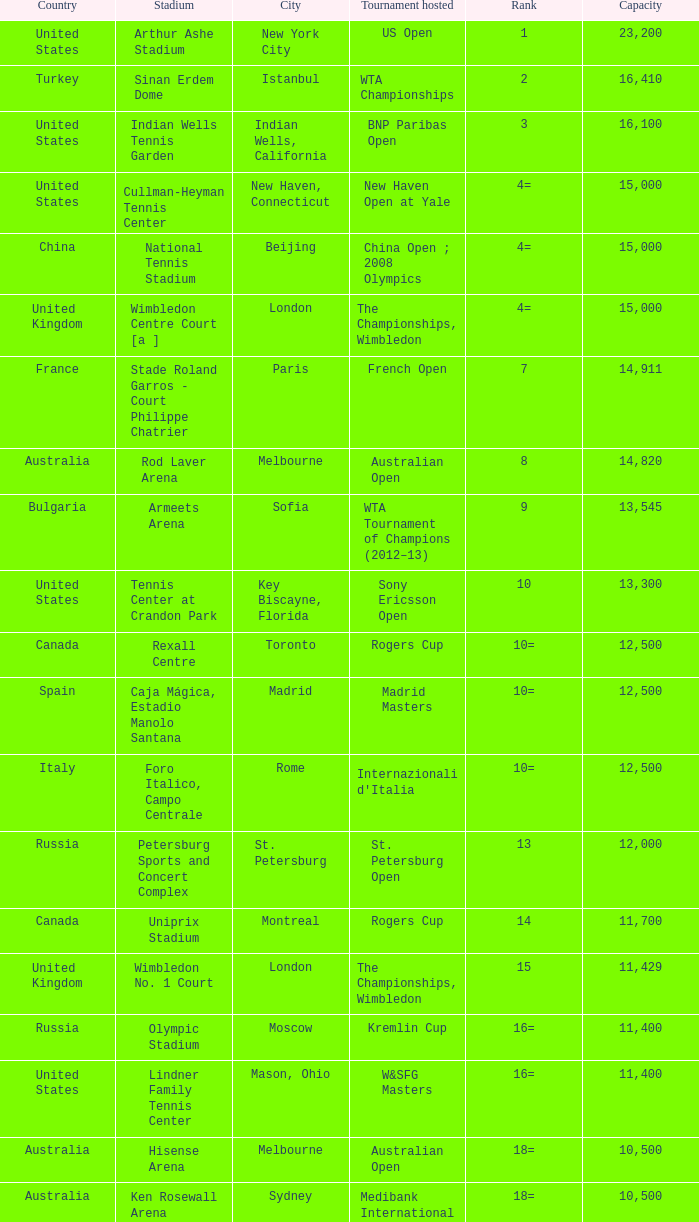What country has grandstand stadium as the stadium? United States. 